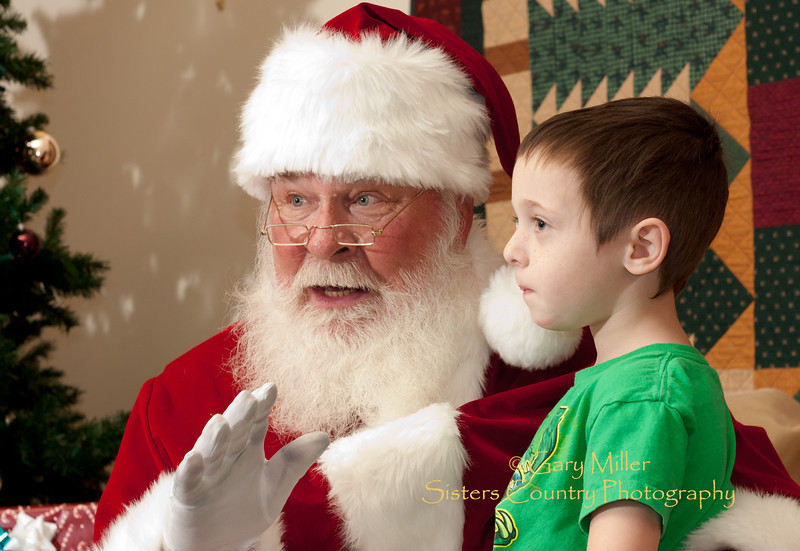What details in the background suggest a Christmas setting? The background of the image displays several features that suggest a Christmas setting. Noticeably, there's a Christmas tree adorned with lights and ornaments, visible in the soft blur behind them. Additionally, the quilt with holiday motifs and the twinkling lights contribute to creating a festive and cozy environment typical of Christmas celebrations. 